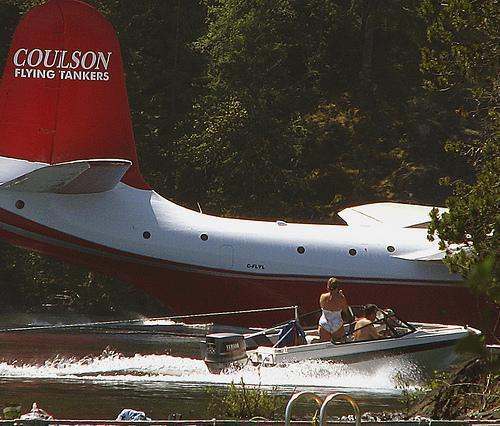Based on the circumstances of the image what method of transportation currently moves the fastest?
From the following four choices, select the correct answer to address the question.
Options: Walking, airplane, motorboat, swimming. Motorboat. 